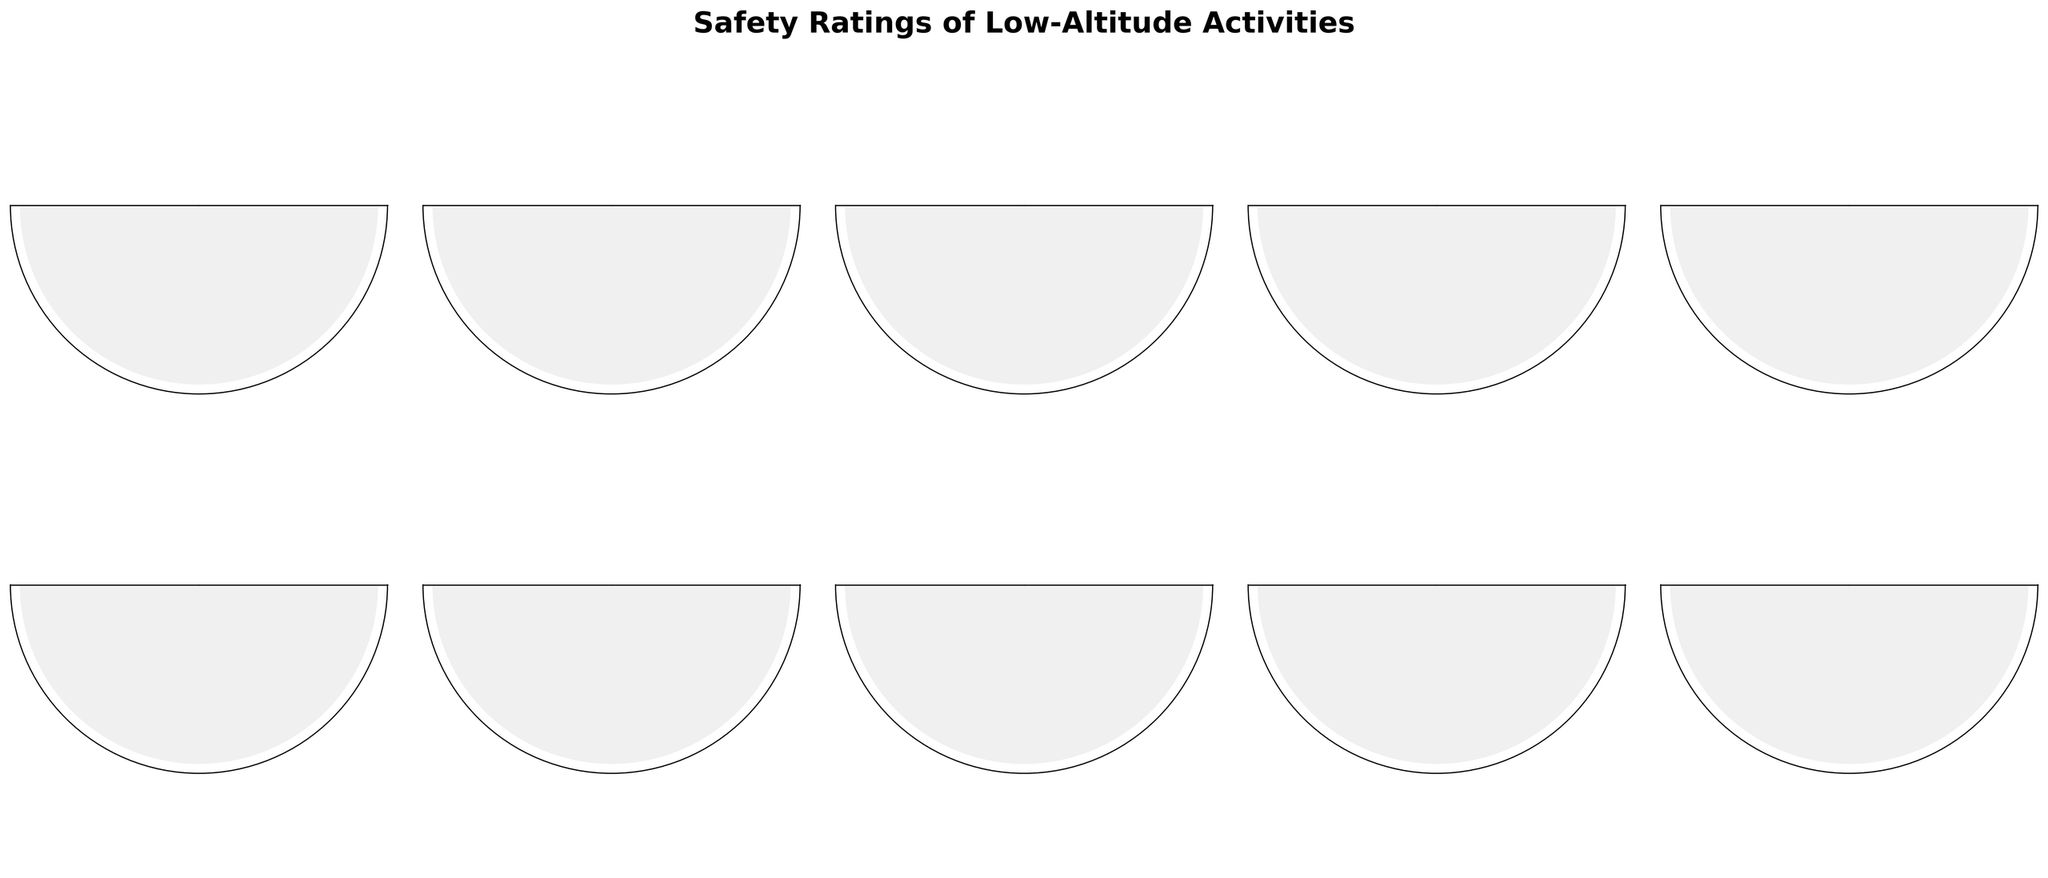How many activities are rated with a safety rating of 80% or higher? Identify and count activities with safety ratings of 80% or more: Indoor rock climbing (85%), Ferris wheel (90%), Observation deck visit (95%), Treehouse stay (80%), and Rooftop restaurant dining (85%).
Answer: 5 What is the safety rating of the Ferris wheel? Look for the Ferris wheel label and its corresponding gauge which indicates the safety rating.
Answer: 90% Which activity has the lowest safety rating? Compare the safety ratings of all activities and find the lowest value. The activity with a safety rating of 55% is Parasailing.
Answer: Parasailing What is the difference in safety rating between Indoor rock climbing and Parasailing? Subtract the safety rating of Parasailing (55%) from the safety rating of Indoor rock climbing (85%): 85% - 55%.
Answer: 30% Which activity is considered the safest according to the chart? Identify the activity with the highest safety rating. The highest safety rating is 95% for Observation deck visit.
Answer: Observation deck visit What is the average safety rating of all the activities shown? Add together all safety ratings: 85 + 75 + 70 + 65 + 90 + 95 + 60 + 55 + 80 + 85 = 760. Divide sum by number of activities (10): 760 / 10.
Answer: 76% Is Zip lining considered safer than Treehouse stay? Compare the safety ratings of Zip lining (75%) and Treehouse stay (80%).
Answer: No How many activities have a safety rating between 60% and 80%? Identify activities with safety ratings from 60% to 80% inclusive: Zip lining (75%), Hot air balloon ride (70%), Glass-bottom skywalk (65%), Low-level helicopter tour (60%), Treehouse stay (80%). Count these activities.
Answer: 5 Which activity has a higher safety rating: Hot air balloon ride or Glass-bottom skywalk? Compare the safety ratings of Hot air balloon ride (70%) and Glass-bottom skywalk (65%).
Answer: Hot air balloon ride If all activities above 75% are considered "safe," which activities fall into this category? Identify activities with safety ratings above 75%: Indoor rock climbing (85%), Ferris wheel (90%), Observation deck visit (95%), Treehouse stay (80%), and Rooftop restaurant dining (85%).
Answer: 5 